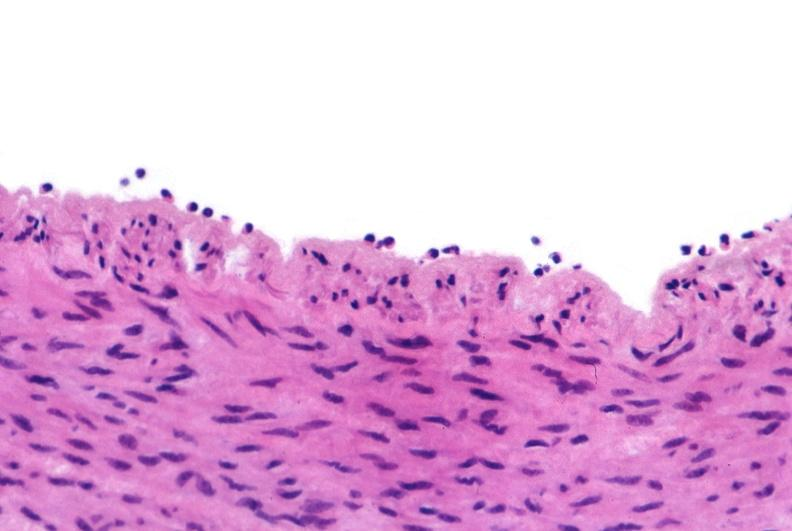does mesothelioma show acute inflammation, rolling leukocytes polymorphonuclear neutrophils?
Answer the question using a single word or phrase. No 